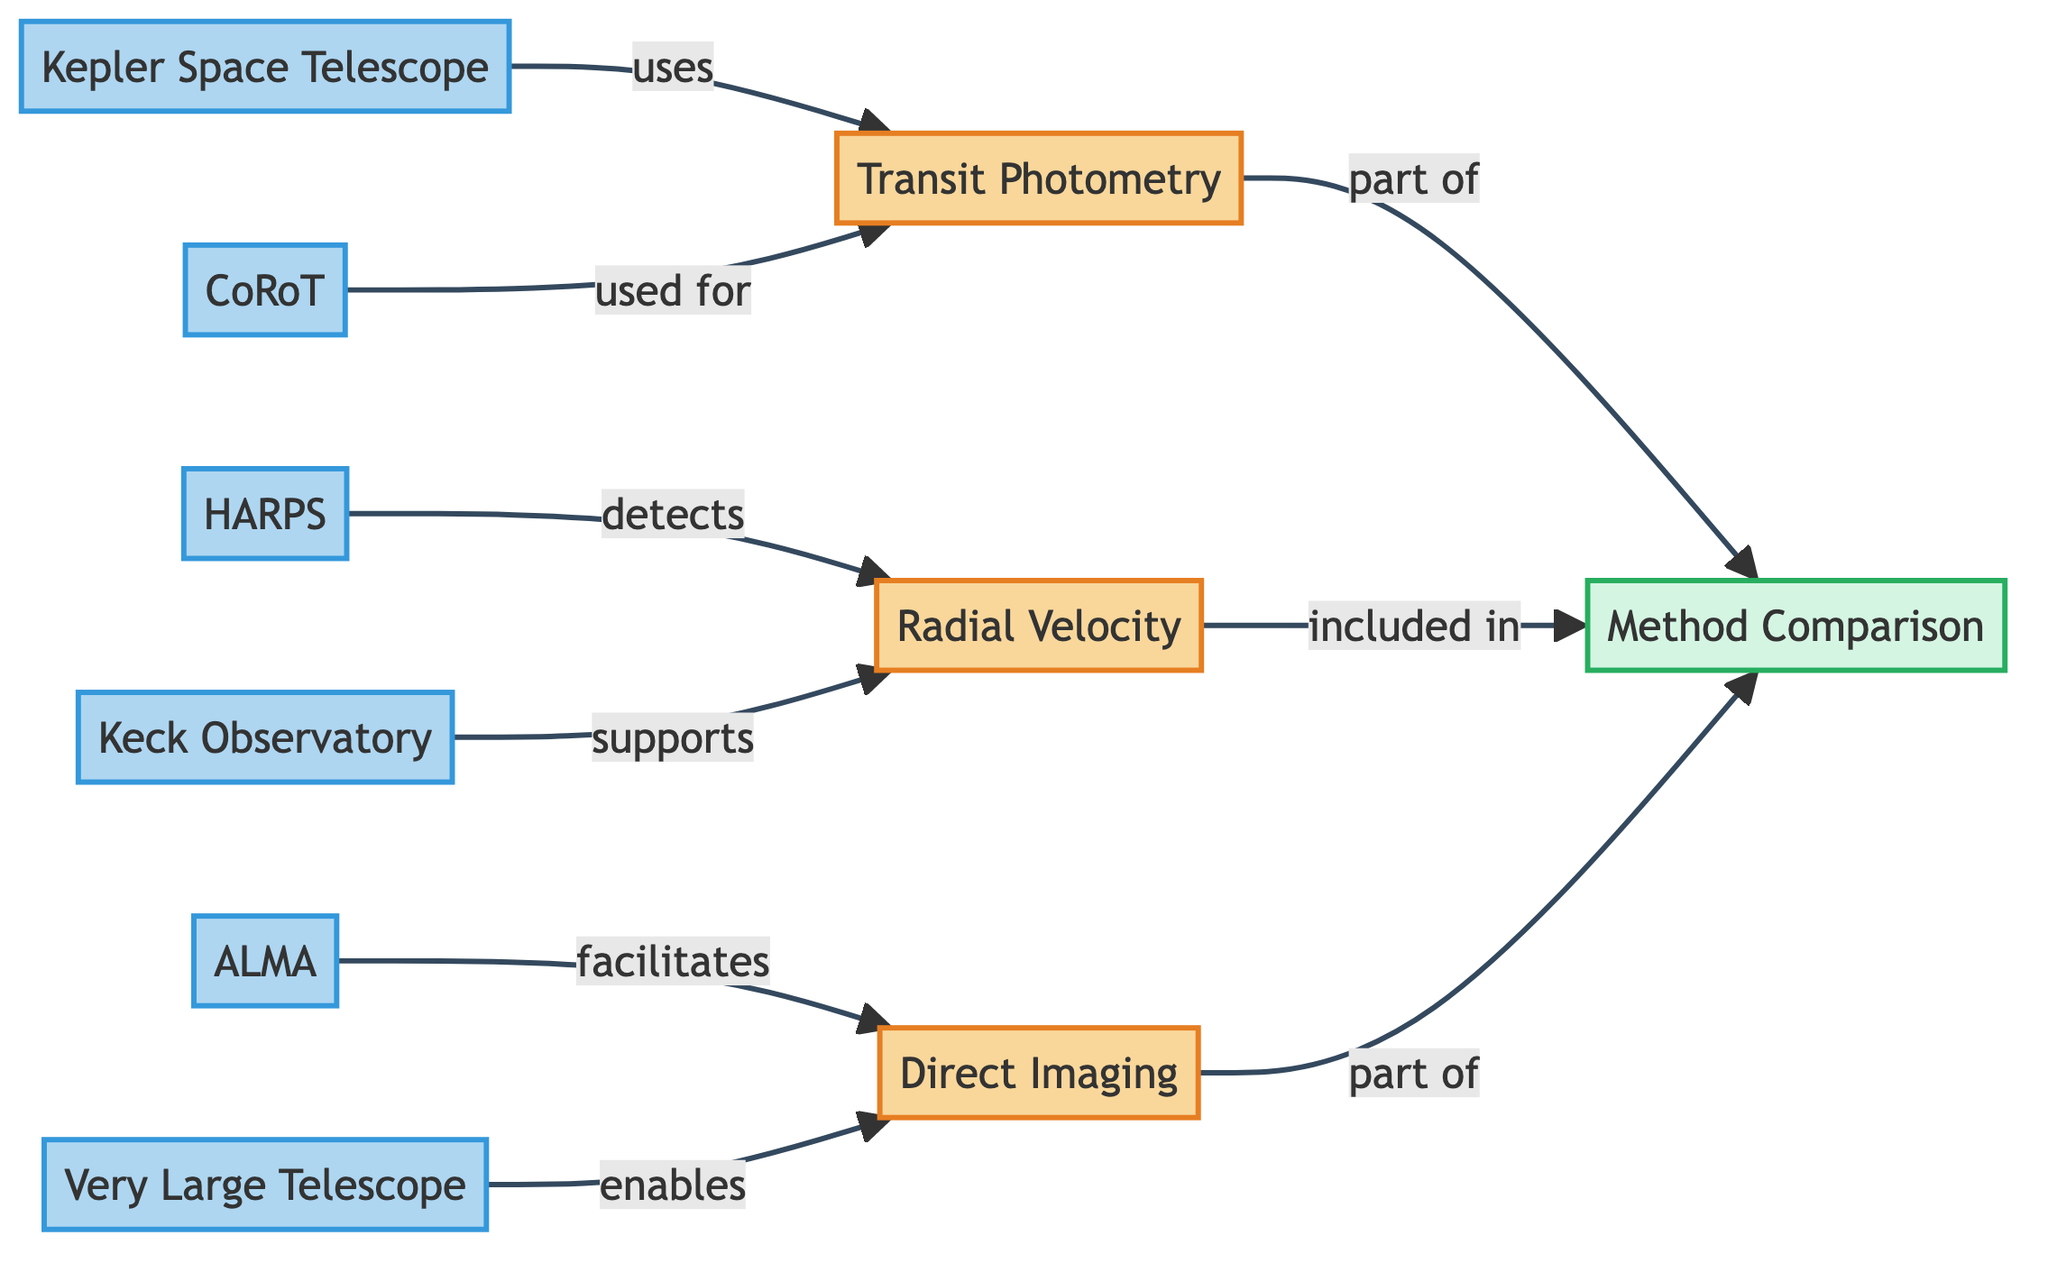What are the three main detection methods shown in the diagram? The diagram lists three main detection methods: Transit Photometry, Radial Velocity, and Direct Imaging. This can be inferred from the three labeled boxes for each method within the main flowchart.
Answer: Transit Photometry, Radial Velocity, Direct Imaging Which telescope is associated with the Transit Photometry method? The diagram indicates that the Kepler Space Telescope and CoRoT are associated with the Transit Photometry method, as these tools are directed towards that method in the flowchart.
Answer: Kepler Space Telescope, CoRoT How many tools are listed under the Radial Velocity detection method? The diagram shows two tools that are associated with the Radial Velocity detection method: HARPS and Keck Observatory. Therefore, the count of tools under this method is two.
Answer: 2 What method does the Very Large Telescope enable? The diagram connects the Very Large Telescope to the Direct Imaging method, indicating that it facilitates this particular detection technique. Therefore, the relationship shows that VLT enables Direct Imaging.
Answer: Direct Imaging Which method is a part of the Method Comparison? The diagram has a node titled "Method Comparison" that explicitly lists Transit Photometry, Radial Velocity, and Direct Imaging as its components. Thus, all three methods are included in this comparison.
Answer: Transit Photometry, Radial Velocity, Direct Imaging What is the role of HARPS in the diagram? According to the diagram, HARPS is utilized to detect Radial Velocity as indicated by the arrow and labeled relationship that connects the HARPS tool to the Radial Velocity detection method.
Answer: Detects Radial Velocity How many detection methods are included in the Method Comparison? The Method Comparison node includes all three detection methods (Transit Photometry, Radial Velocity, and Direct Imaging), which can be counted directly from the connections leading to this comparison node.
Answer: 3 Which detection method involves direct observation of exoplanets? The diagram indicates that Direct Imaging is the method that involves direct observation of exoplanets, as it is specifically labeled and represented in the flowchart.
Answer: Direct Imaging 